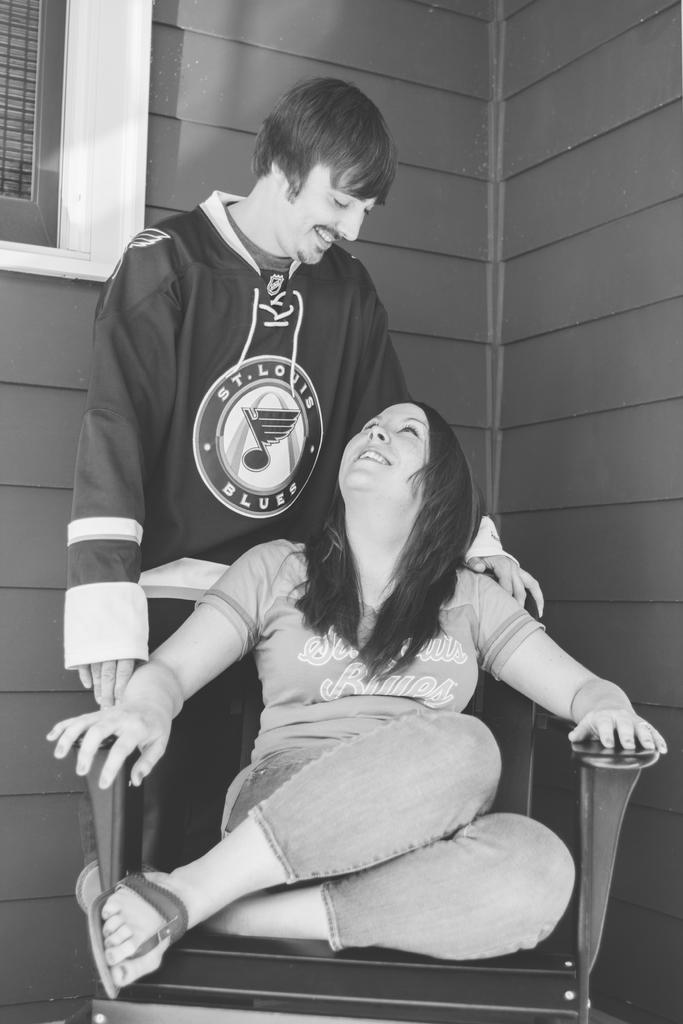<image>
Relay a brief, clear account of the picture shown. Man wearing a jersey which says "St.Louis Blues" standing by a woman. 